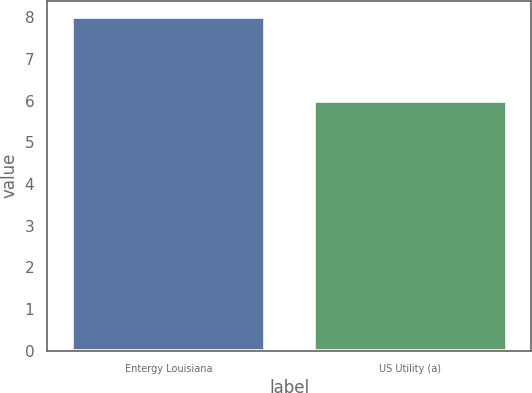Convert chart. <chart><loc_0><loc_0><loc_500><loc_500><bar_chart><fcel>Entergy Louisiana<fcel>US Utility (a)<nl><fcel>8<fcel>6<nl></chart> 